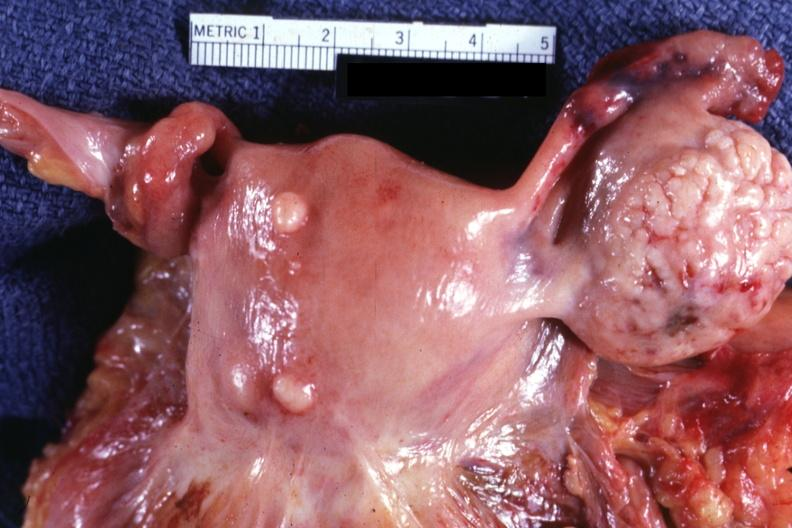do adenoma represent?
Answer the question using a single word or phrase. No 